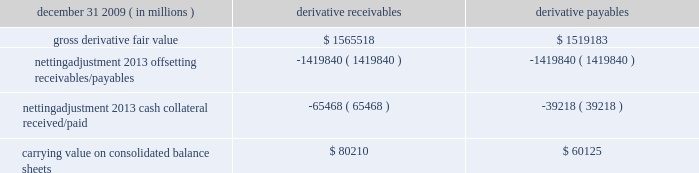Jpmorgan chase & co./2009 annual report 181 the table shows the current credit risk of derivative receivables after netting adjustments , and the current liquidity risk of derivative payables after netting adjustments , as of december 31 , 2009. .
In addition to the collateral amounts reflected in the table above , at december 31 , 2009 , the firm had received and posted liquid secu- rities collateral in the amount of $ 15.5 billion and $ 11.7 billion , respectively .
The firm also receives and delivers collateral at the initiation of derivative transactions , which is available as security against potential exposure that could arise should the fair value of the transactions move in the firm 2019s or client 2019s favor , respectively .
Furthermore , the firm and its counterparties hold collateral related to contracts that have a non-daily call frequency for collateral to be posted , and collateral that the firm or a counterparty has agreed to return but has not yet settled as of the reporting date .
At december 31 , 2009 , the firm had received $ 16.9 billion and delivered $ 5.8 billion of such additional collateral .
These amounts were not netted against the derivative receivables and payables in the table above , because , at an individual counterparty level , the collateral exceeded the fair value exposure at december 31 , 2009 .
Credit derivatives credit derivatives are financial instruments whose value is derived from the credit risk associated with the debt of a third-party issuer ( the reference entity ) and which allow one party ( the protection purchaser ) to transfer that risk to another party ( the protection seller ) .
Credit derivatives expose the protection purchaser to the creditworthiness of the protection seller , as the protection seller is required to make payments under the contract when the reference entity experiences a credit event , such as a bankruptcy , a failure to pay its obligation or a restructuring .
The seller of credit protection receives a premium for providing protection but has the risk that the underlying instrument referenced in the contract will be subject to a credit event .
The firm is both a purchaser and seller of protection in the credit derivatives market and uses these derivatives for two primary purposes .
First , in its capacity as a market-maker in the dealer/client business , the firm actively risk manages a portfolio of credit derivatives by purchasing and selling credit protection , pre- dominantly on corporate debt obligations , to meet the needs of customers .
As a seller of protection , the firm 2019s exposure to a given reference entity may be offset partially , or entirely , with a contract to purchase protection from another counterparty on the same or similar reference entity .
Second , the firm uses credit derivatives to mitigate credit risk associated with its overall derivative receivables and traditional commercial credit lending exposures ( loans and unfunded commitments ) as well as to manage its exposure to residential and commercial mortgages .
See note 3 on pages 156--- 173 of this annual report for further information on the firm 2019s mortgage-related exposures .
In accomplishing the above , the firm uses different types of credit derivatives .
Following is a summary of various types of credit derivatives .
Credit default swaps credit derivatives may reference the credit of either a single refer- ence entity ( 201csingle-name 201d ) or a broad-based index , as described further below .
The firm purchases and sells protection on both single- name and index-reference obligations .
Single-name cds and index cds contracts are both otc derivative contracts .
Single- name cds are used to manage the default risk of a single reference entity , while cds index are used to manage credit risk associated with the broader credit markets or credit market segments .
Like the s&p 500 and other market indices , a cds index is comprised of a portfolio of cds across many reference entities .
New series of cds indices are established approximately every six months with a new underlying portfolio of reference entities to reflect changes in the credit markets .
If one of the reference entities in the index experi- ences a credit event , then the reference entity that defaulted is removed from the index .
Cds can also be referenced against spe- cific portfolios of reference names or against customized exposure levels based on specific client demands : for example , to provide protection against the first $ 1 million of realized credit losses in a $ 10 million portfolio of exposure .
Such structures are commonly known as tranche cds .
For both single-name cds contracts and index cds , upon the occurrence of a credit event , under the terms of a cds contract neither party to the cds contract has recourse to the reference entity .
The protection purchaser has recourse to the protection seller for the difference between the face value of the cds contract and the fair value of the reference obligation at the time of settling the credit derivative contract , also known as the recovery value .
The protection purchaser does not need to hold the debt instrument of the underlying reference entity in order to receive amounts due under the cds contract when a credit event occurs .
Credit-linked notes a credit linked note ( 201ccln 201d ) is a funded credit derivative where the issuer of the cln purchases credit protection on a referenced entity from the note investor .
Under the contract , the investor pays the issuer par value of the note at the inception of the transaction , and in return , the issuer pays periodic payments to the investor , based on the credit risk of the referenced entity .
The issuer also repays the investor the par value of the note at maturity unless the reference entity experiences a specified credit event .
In that event , the issuer is not obligated to repay the par value of the note , but rather , the issuer pays the investor the difference between the par value of the note .
What was the total collateral of all types december 31 , 2009? 
Computations: (((15.5 * 1000000) * 1000) + (65468 * 1000000))
Answer: 80968000000.0. 